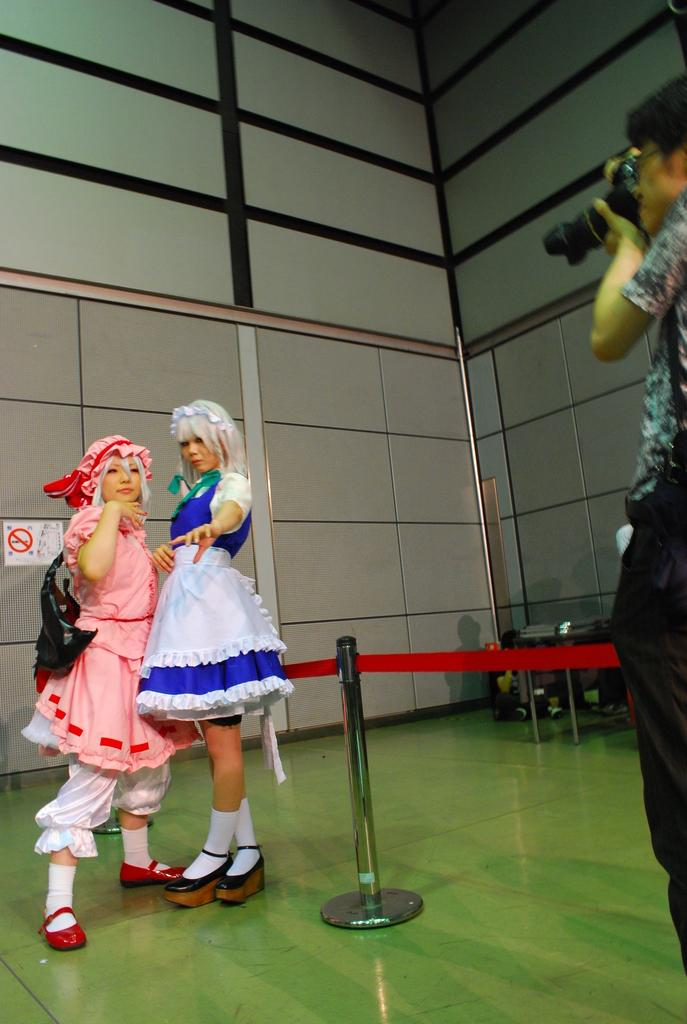How many people are in the image? There are three people in the image: two women and one man. What are the women dressed up as in the image? The women are dressed up like dolls in the image. What are the women doing in the image? The women are posing for a photo in the image. What is the man doing in the image? The man is standing in front of the women and taking a photograph in the image. What degree does the man have in photography, as seen in the image? There is no indication in the image of the man's degree in photography. 